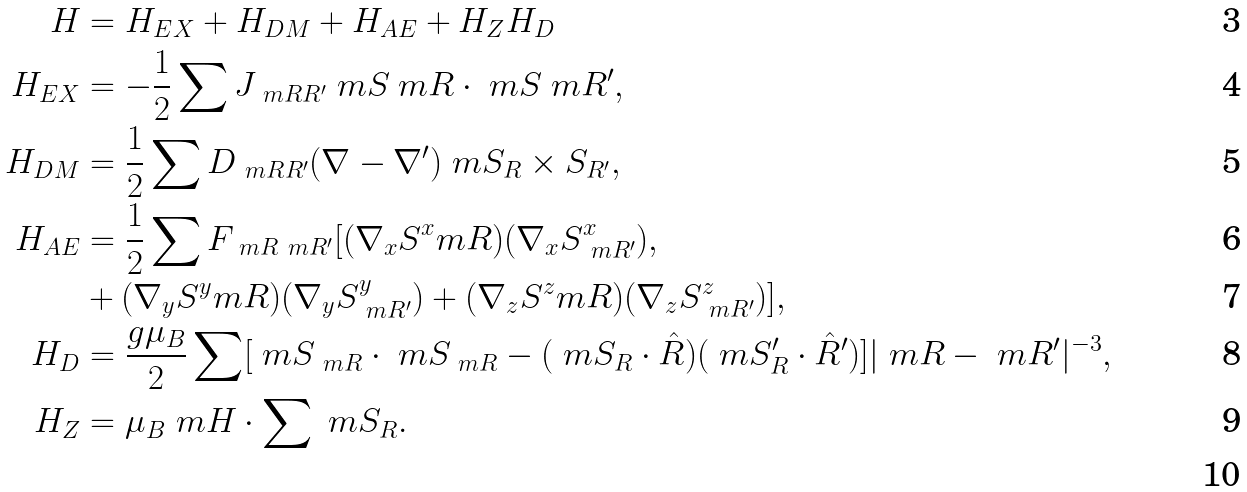Convert formula to latex. <formula><loc_0><loc_0><loc_500><loc_500>H & = H _ { E X } + H _ { D M } + H _ { A E } + H _ { Z } H _ { D } \\ H _ { E X } & = - \frac { 1 } { 2 } \sum J _ { \ m { R R ^ { \prime } } } \ m S _ { \ } m R \cdot \ m S _ { \ } m { R ^ { \prime } } , \\ H _ { D M } & = \frac { 1 } { 2 } \sum D _ { \ m { R R ^ { \prime } } } ( \nabla - \nabla ^ { \prime } ) \ m { S _ { R } \times S _ { R ^ { \prime } } } , \\ H _ { A E } & = \frac { 1 } { 2 } \sum F _ { \ m R \ m R ^ { \prime } } [ ( \nabla _ { x } S ^ { x } _ { \ } m R ) ( \nabla _ { x } S ^ { x } _ { \ m R ^ { \prime } } ) , \\ & + ( \nabla _ { y } S ^ { y } _ { \ } m R ) ( \nabla _ { y } S ^ { y } _ { \ m R ^ { \prime } } ) + ( \nabla _ { z } S ^ { z } _ { \ } m R ) ( \nabla _ { z } S ^ { z } _ { \ m R ^ { \prime } } ) ] , \\ H _ { D } & = \frac { g \mu _ { B } } { 2 } \sum [ \ m S _ { \ m R } \cdot \ m S _ { \ m R } - ( \ m { S _ { R } } \cdot \hat { R } ) ( \ m { S _ { R } ^ { \prime } } \cdot \hat { R } ^ { \prime } ) ] | \ m R - \ m R ^ { \prime } | ^ { - 3 } , \\ H _ { Z } & = \mu _ { B } \ m H \cdot \sum \ m { S _ { R } } . \\</formula> 